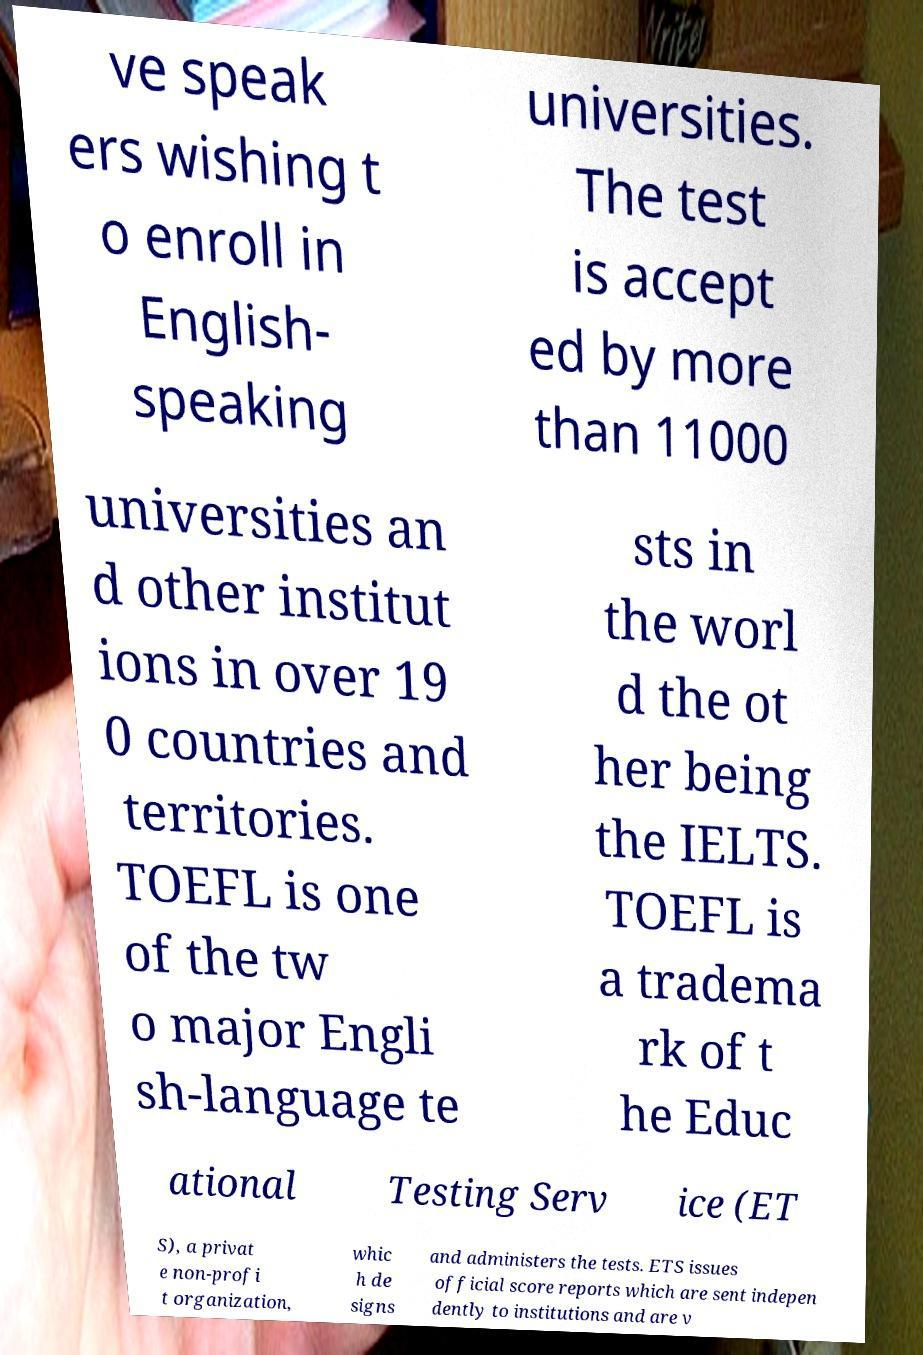For documentation purposes, I need the text within this image transcribed. Could you provide that? ve speak ers wishing t o enroll in English- speaking universities. The test is accept ed by more than 11000 universities an d other institut ions in over 19 0 countries and territories. TOEFL is one of the tw o major Engli sh-language te sts in the worl d the ot her being the IELTS. TOEFL is a tradema rk of t he Educ ational Testing Serv ice (ET S), a privat e non-profi t organization, whic h de signs and administers the tests. ETS issues official score reports which are sent indepen dently to institutions and are v 